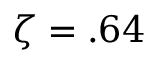Convert formula to latex. <formula><loc_0><loc_0><loc_500><loc_500>\zeta = . 6 4</formula> 